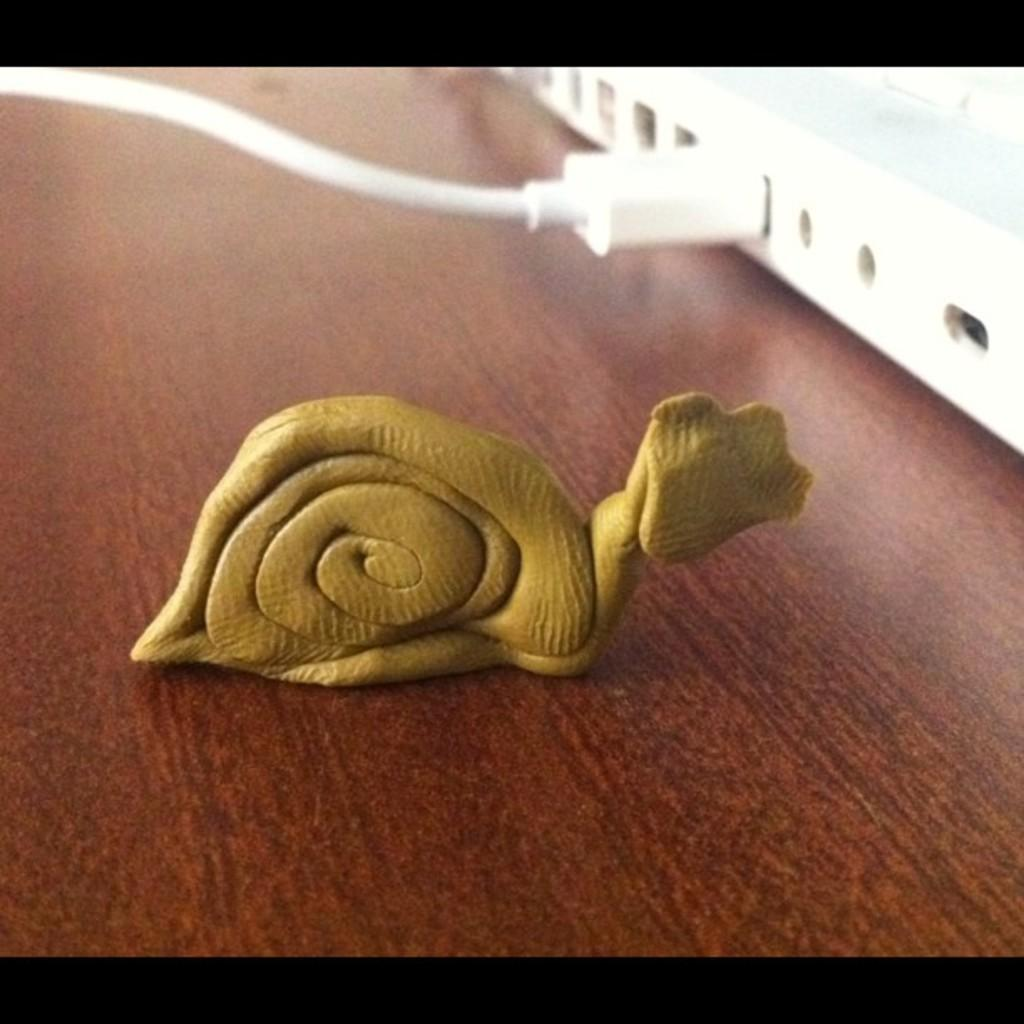What type of object can be seen in the image? There is a toy in the image. Where is the object located on the right side of the image? There is an object at the right side of the image. What can be seen connected to the object on the right side? There is a cable in the image. What type of surface is visible in the image? There is a wooden surface in the image. What type of crime is being committed in the image? There is no indication of any crime being committed in the image. The image features a toy, an object on the right side, a cable, and a wooden surface. 